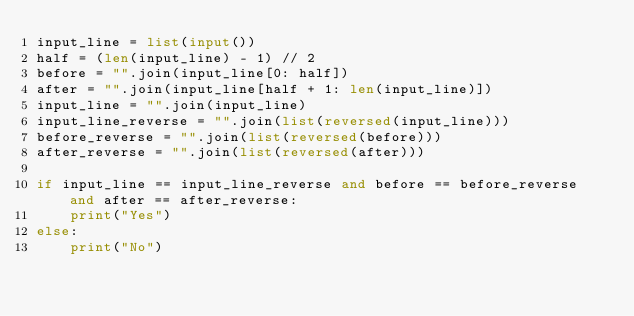Convert code to text. <code><loc_0><loc_0><loc_500><loc_500><_Python_>input_line = list(input())
half = (len(input_line) - 1) // 2
before = "".join(input_line[0: half])
after = "".join(input_line[half + 1: len(input_line)])
input_line = "".join(input_line)
input_line_reverse = "".join(list(reversed(input_line)))
before_reverse = "".join(list(reversed(before)))
after_reverse = "".join(list(reversed(after)))

if input_line == input_line_reverse and before == before_reverse and after == after_reverse:
    print("Yes")
else:
    print("No")
</code> 